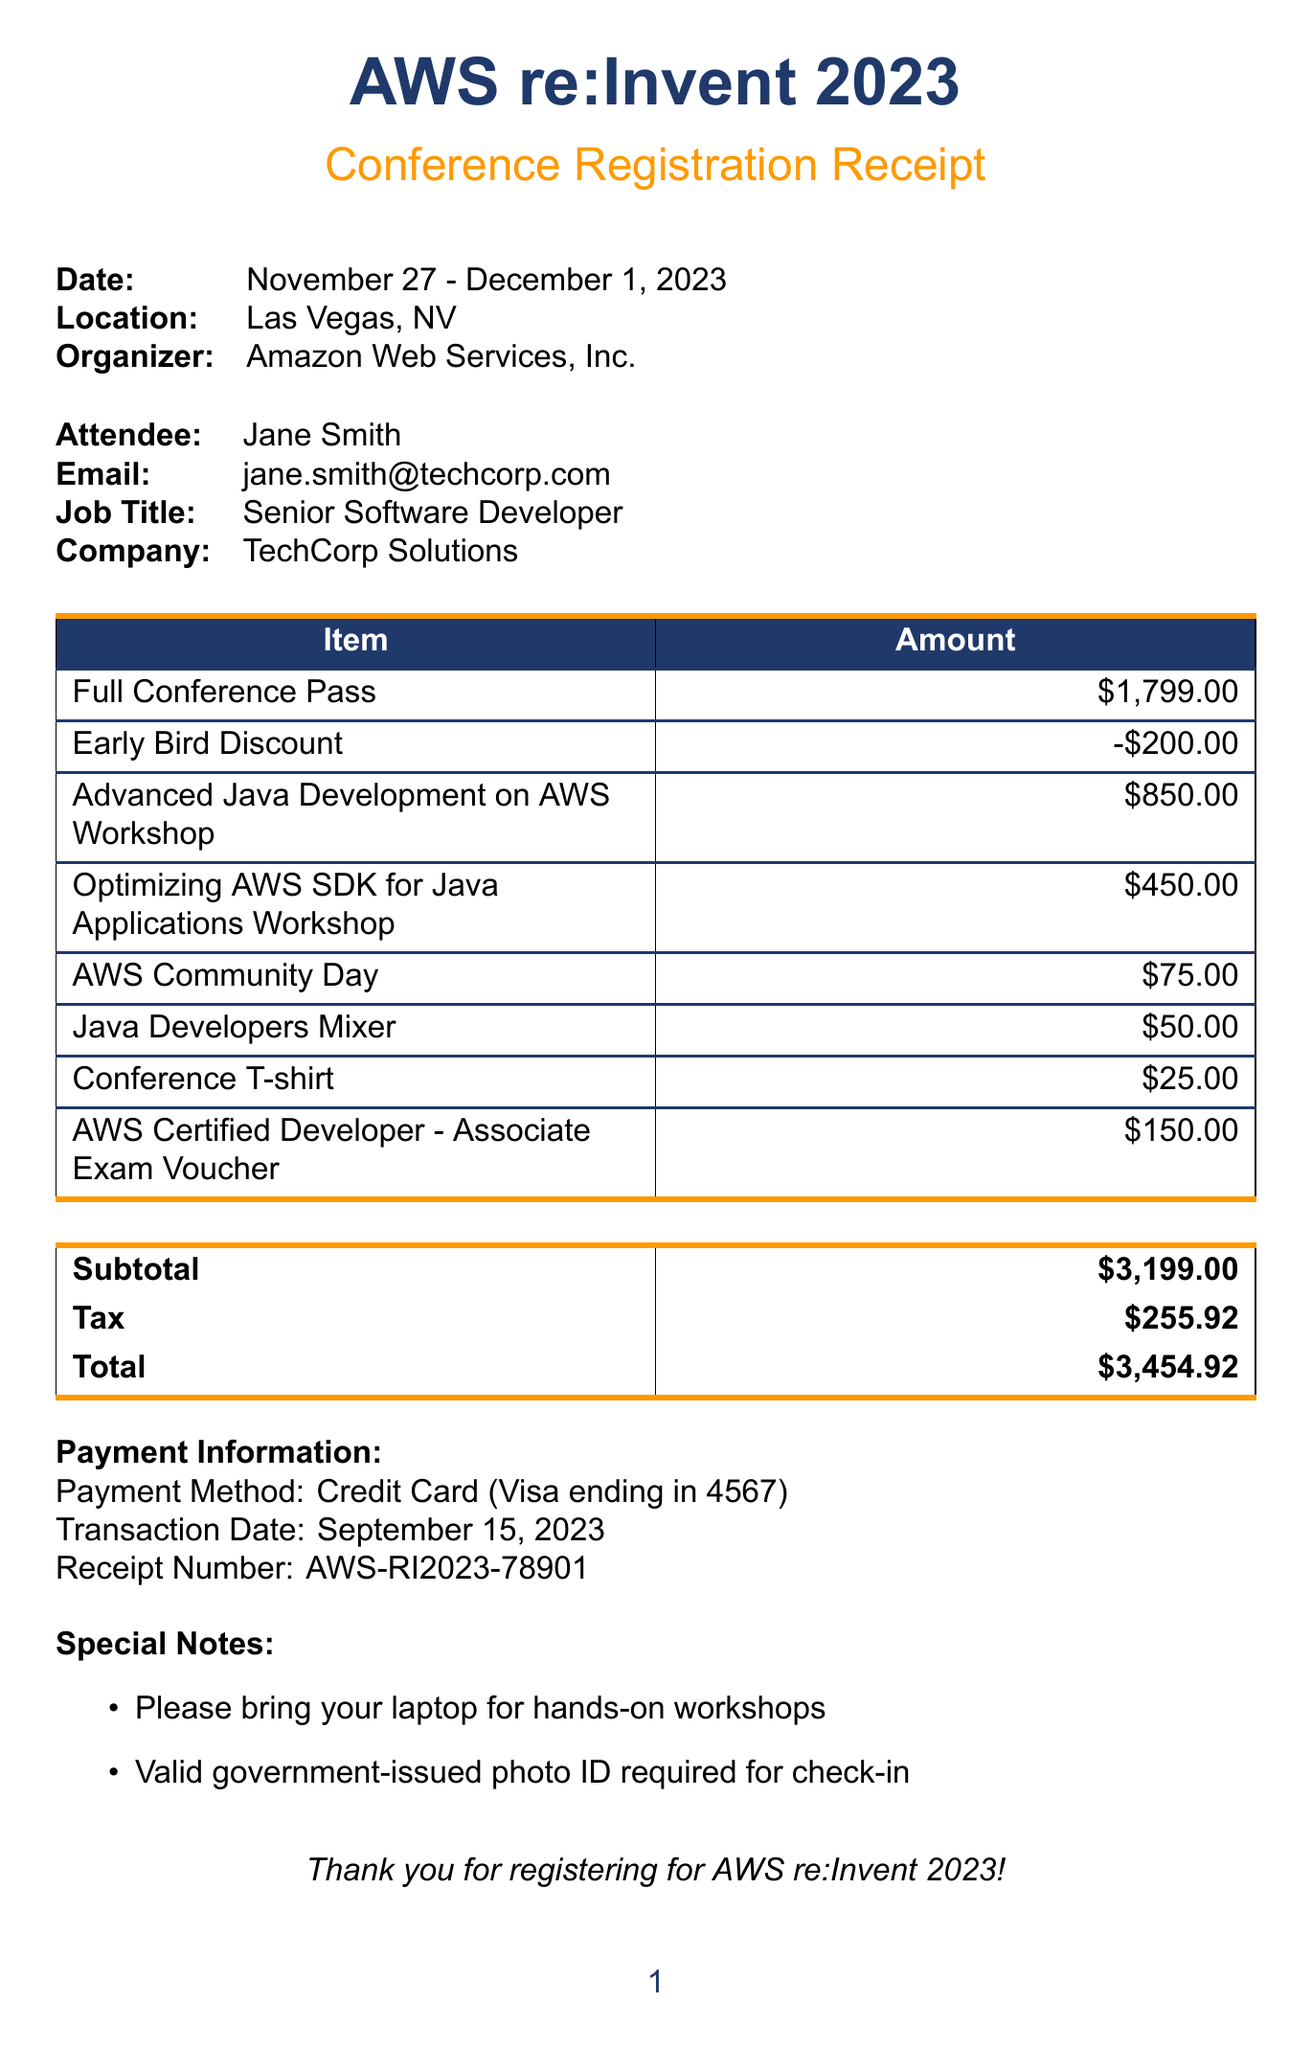What is the name of the conference? The name of the conference is stated prominently at the top of the document as "AWS re:Invent 2023."
Answer: AWS re:Invent 2023 What is the total amount charged? The total amount is listed in the payment information section as the final calculation of the costs.
Answer: $3,454.92 Who is the organizer of the event? The document specifies the organizer in the conference details section.
Answer: Amazon Web Services, Inc What is the date of the Advanced Java Development workshop? The date is clearly mentioned next to the workshop details in the document.
Answer: November 27, 2023 How much is the fee for the AWS Community Day? The fee is detailed in the networking events section of the document.
Answer: $75.00 What is the early bird discount amount? The discount amount is negative and appears next to the full conference pass fee.
Answer: -$200.00 Which payment method was used? The payment method is specified in the payment information section.
Answer: Credit Card How many networking events are listed in the receipt? The number of networking events can be determined by counting the entries in that section of the document.
Answer: 2 What special instruction is provided for the workshops? Special notes include instructions relevant for attending the workshops.
Answer: Please bring your laptop for hands-on workshops 